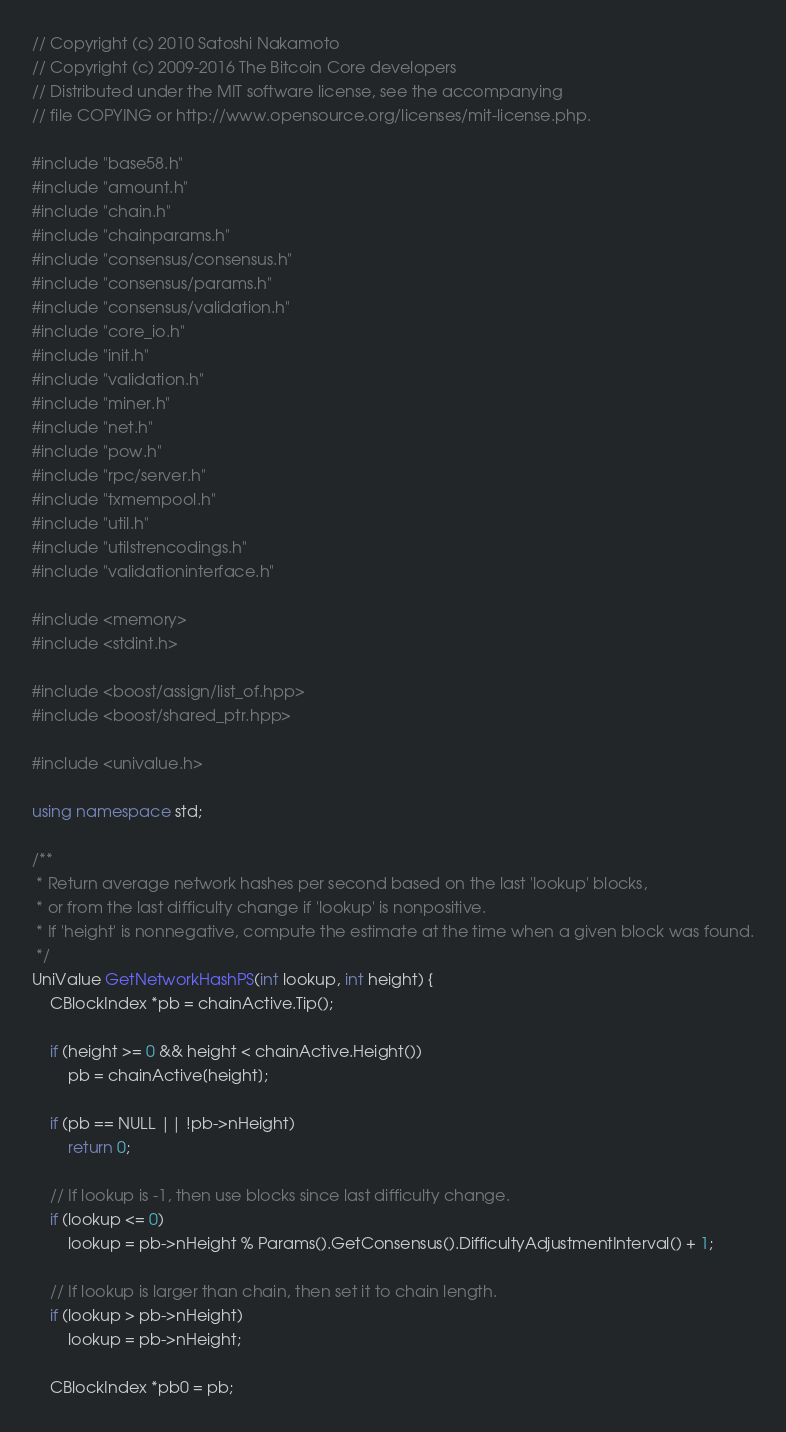Convert code to text. <code><loc_0><loc_0><loc_500><loc_500><_C++_>// Copyright (c) 2010 Satoshi Nakamoto
// Copyright (c) 2009-2016 The Bitcoin Core developers
// Distributed under the MIT software license, see the accompanying
// file COPYING or http://www.opensource.org/licenses/mit-license.php.

#include "base58.h"
#include "amount.h"
#include "chain.h"
#include "chainparams.h"
#include "consensus/consensus.h"
#include "consensus/params.h"
#include "consensus/validation.h"
#include "core_io.h"
#include "init.h"
#include "validation.h"
#include "miner.h"
#include "net.h"
#include "pow.h"
#include "rpc/server.h"
#include "txmempool.h"
#include "util.h"
#include "utilstrencodings.h"
#include "validationinterface.h"

#include <memory>
#include <stdint.h>

#include <boost/assign/list_of.hpp>
#include <boost/shared_ptr.hpp>

#include <univalue.h>

using namespace std;

/**
 * Return average network hashes per second based on the last 'lookup' blocks,
 * or from the last difficulty change if 'lookup' is nonpositive.
 * If 'height' is nonnegative, compute the estimate at the time when a given block was found.
 */
UniValue GetNetworkHashPS(int lookup, int height) {
    CBlockIndex *pb = chainActive.Tip();

    if (height >= 0 && height < chainActive.Height())
        pb = chainActive[height];

    if (pb == NULL || !pb->nHeight)
        return 0;

    // If lookup is -1, then use blocks since last difficulty change.
    if (lookup <= 0)
        lookup = pb->nHeight % Params().GetConsensus().DifficultyAdjustmentInterval() + 1;

    // If lookup is larger than chain, then set it to chain length.
    if (lookup > pb->nHeight)
        lookup = pb->nHeight;

    CBlockIndex *pb0 = pb;</code> 